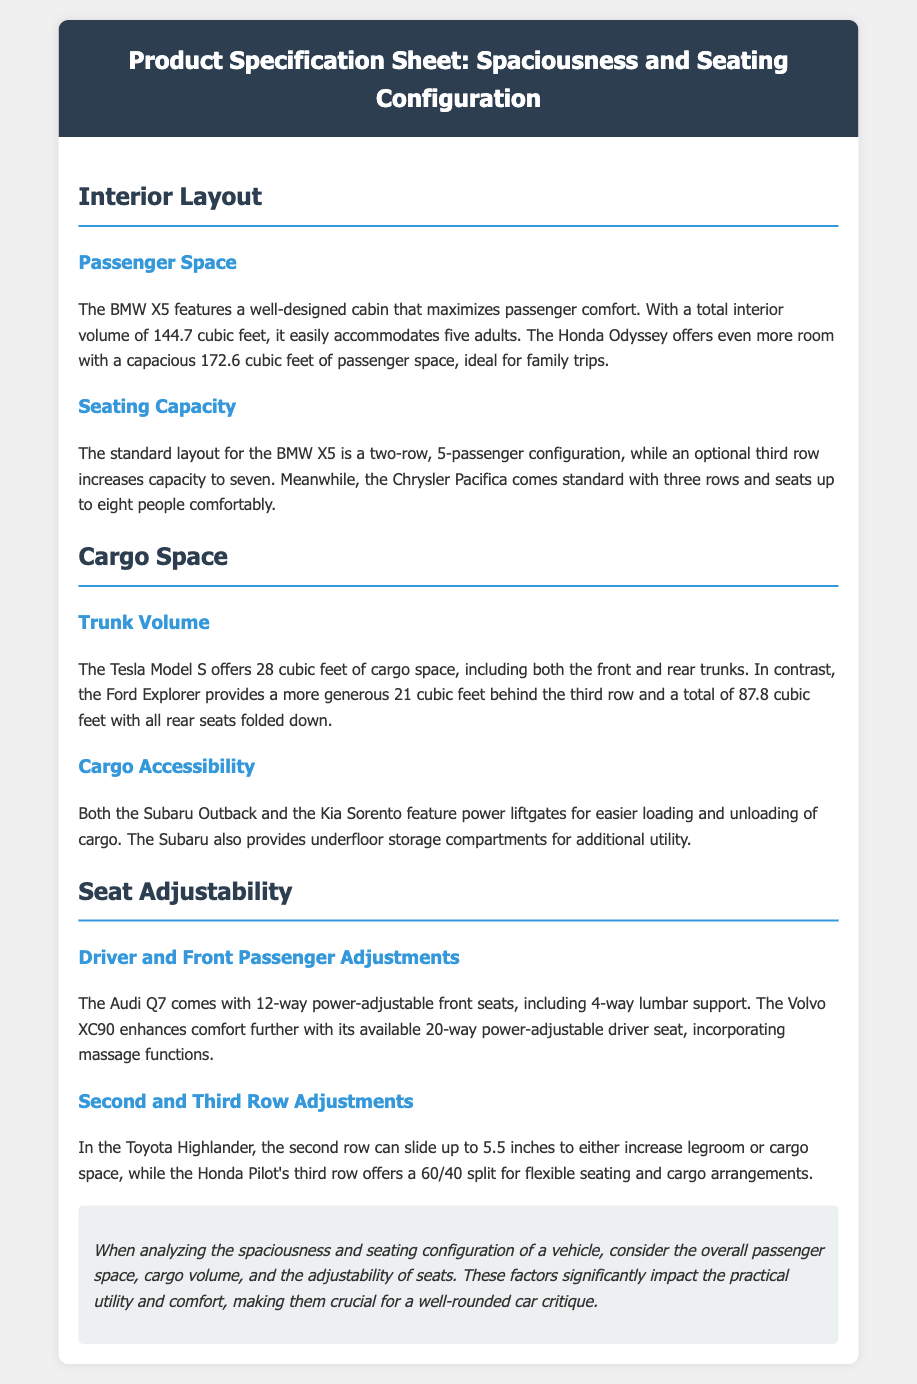What is the total interior volume of the BMW X5? The total interior volume of the BMW X5 is specified to be 144.7 cubic feet.
Answer: 144.7 cubic feet What is the seating capacity of the Chrysler Pacifica? The Chrysler Pacifica comes standard with three rows and seats up to eight people.
Answer: eight people How much cargo space does the Tesla Model S offer? The Tesla Model S provides a total of 28 cubic feet of cargo space.
Answer: 28 cubic feet What feature does the Subaru Outback have for cargo accessibility? The Subaru Outback features power liftgates for easier loading and unloading of cargo.
Answer: power liftgates How can the second row in the Toyota Highlander be adjusted? The second row in the Toyota Highlander can slide up to 5.5 inches to either increase legroom or cargo space.
Answer: 5.5 inches What is unique about the driver seat of the Volvo XC90? The Volvo XC90 has an available 20-way power-adjustable driver seat, including massage functions.
Answer: 20-way power-adjustable How many cubic feet of cargo space does the Ford Explorer provide with all rear seats folded down? The Ford Explorer provides a total of 87.8 cubic feet with all rear seats folded down.
Answer: 87.8 cubic feet What is the split configuration for the Honda Pilot's third row? The third row of the Honda Pilot offers a 60/40 split for flexible seating and cargo arrangements.
Answer: 60/40 split What factors should be considered when analyzing a vehicle’s spaciousness? The factors to consider include overall passenger space, cargo volume, and the adjustability of seats.
Answer: passenger space, cargo volume, seat adjustability 